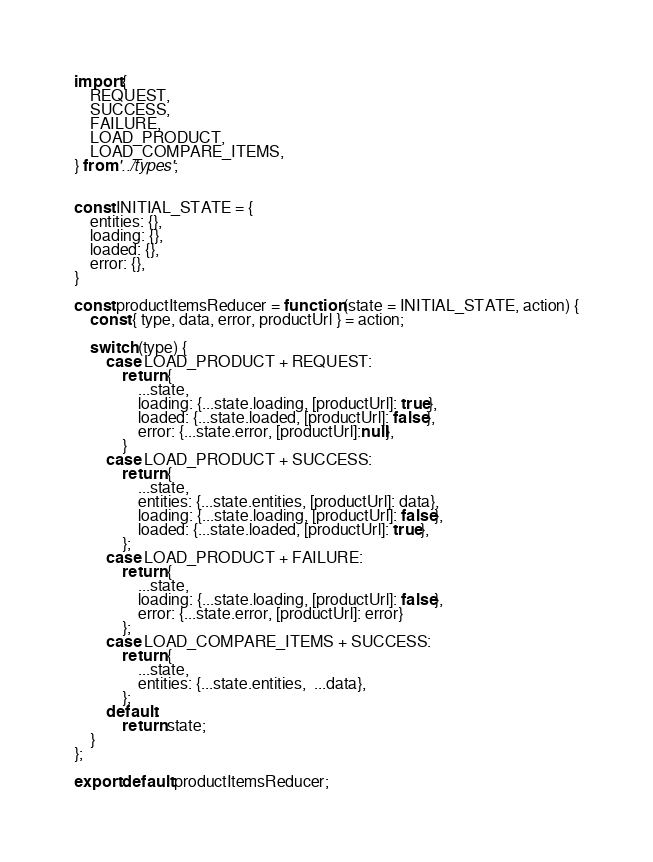<code> <loc_0><loc_0><loc_500><loc_500><_JavaScript_>import {
    REQUEST,
    SUCCESS, 
    FAILURE, 
    LOAD_PRODUCT,
    LOAD_COMPARE_ITEMS,
} from '../types';


const INITIAL_STATE = {
    entities: {},
    loading: {},
    loaded: {},
    error: {},
}

const productItemsReducer = function (state = INITIAL_STATE, action) {
    const { type, data, error, productUrl } = action;

    switch (type) {
        case LOAD_PRODUCT + REQUEST:
            return {
                ...state,
                loading: {...state.loading, [productUrl]: true},
                loaded: {...state.loaded, [productUrl]: false},
                error: {...state.error, [productUrl]:null},
            }
        case LOAD_PRODUCT + SUCCESS:
            return {
                ...state,
                entities: {...state.entities, [productUrl]: data},
                loading: {...state.loading, [productUrl]: false},
                loaded: {...state.loaded, [productUrl]: true},
            };
        case LOAD_PRODUCT + FAILURE:
            return {
                ...state,
                loading: {...state.loading, [productUrl]: false},
                error: {...state.error, [productUrl]: error}
            };
        case LOAD_COMPARE_ITEMS + SUCCESS:
            return {
                ...state,
                entities: {...state.entities,  ...data},
            };
        default:
            return state;
    }
};

export default productItemsReducer;</code> 